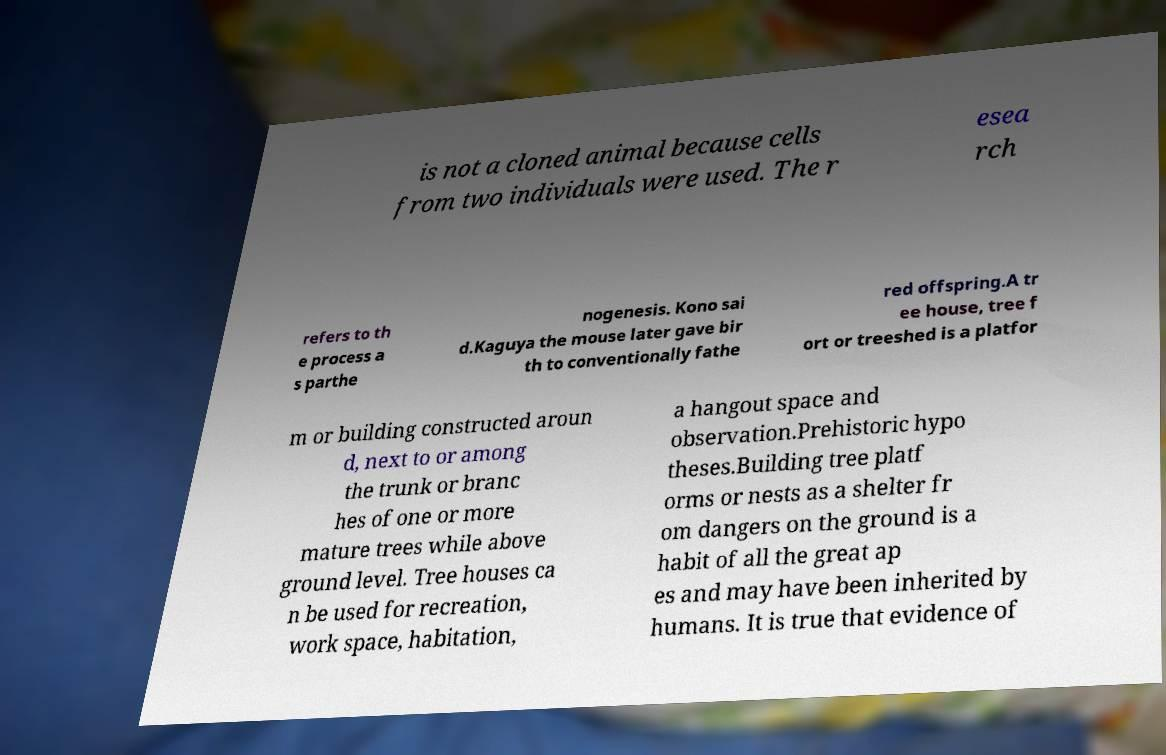I need the written content from this picture converted into text. Can you do that? is not a cloned animal because cells from two individuals were used. The r esea rch refers to th e process a s parthe nogenesis. Kono sai d.Kaguya the mouse later gave bir th to conventionally fathe red offspring.A tr ee house, tree f ort or treeshed is a platfor m or building constructed aroun d, next to or among the trunk or branc hes of one or more mature trees while above ground level. Tree houses ca n be used for recreation, work space, habitation, a hangout space and observation.Prehistoric hypo theses.Building tree platf orms or nests as a shelter fr om dangers on the ground is a habit of all the great ap es and may have been inherited by humans. It is true that evidence of 